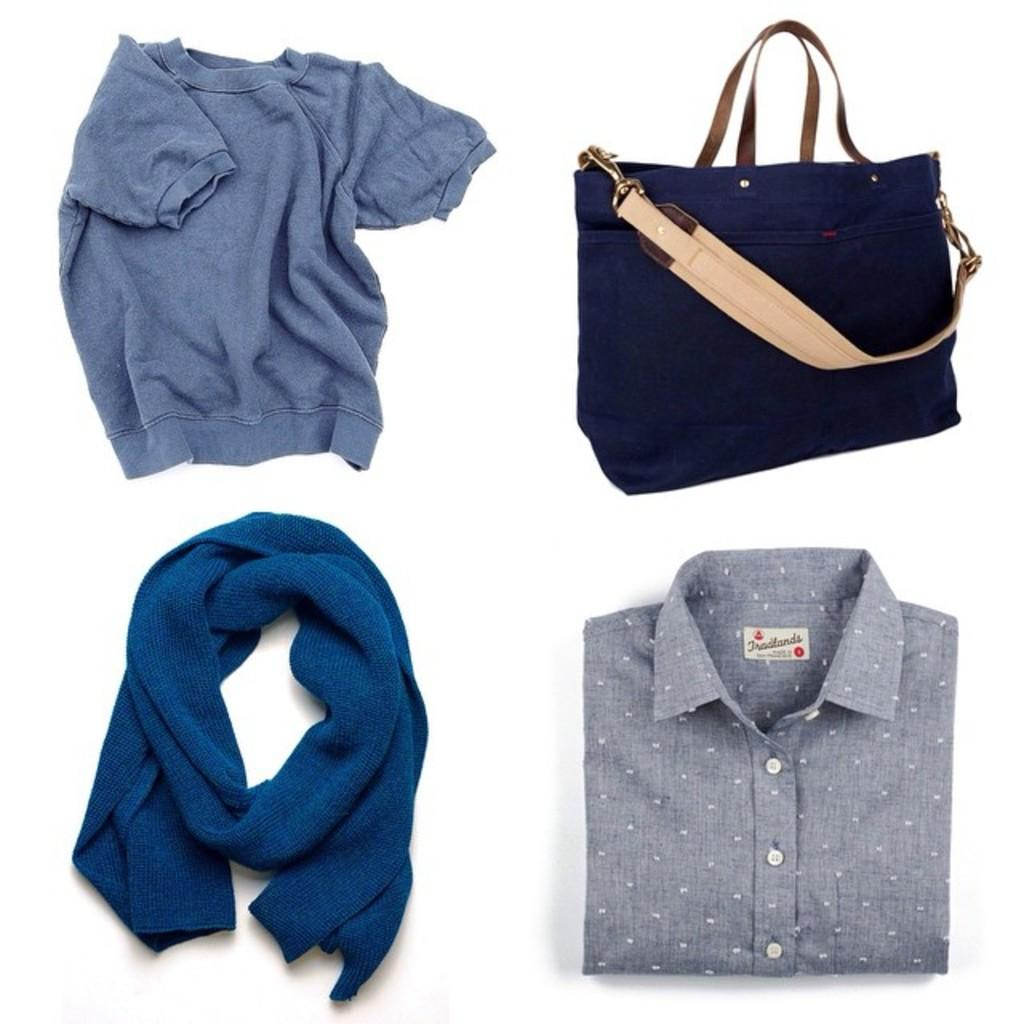What items are in the foreground of the image? There is a scarf and a shirt in the foreground of the image. What is located on the top of the image? There is a shirt and a handbag on the top of the image. What type of spark can be seen in the field in the image? There is no spark or field present in the image; it features a scarf, shirt, and handbag. What color is the gold object in the image? There is no gold object present in the image. 